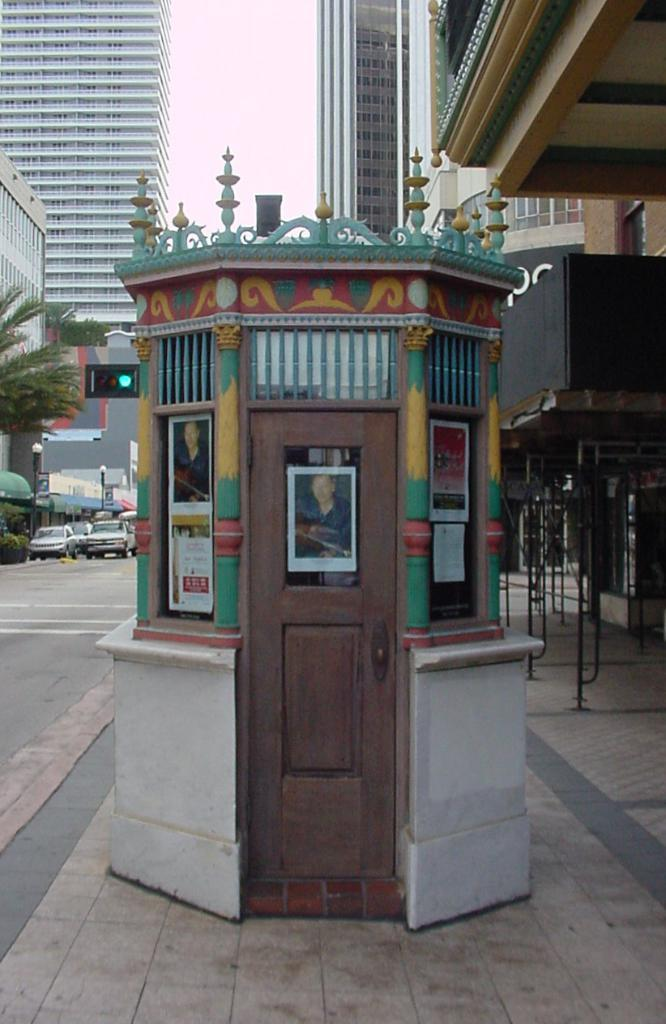What is the main subject in the center of the image? There is a booth in the center of the image. What can be seen in the background of the image? There are buildings, trees, cars, poles, and the sky visible in the background of the image. What type of grass is growing on the wing of the car in the image? There is no grass or wing of a car present in the image. 